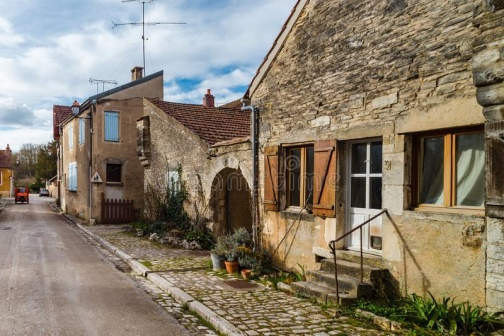Can you tell me more about the architectural style of the houses? The houses in the image showcase typical features of rural European architecture, often seen in small villages. They are constructed with natural stone walls and are topped with terracotta-colored tile roofs, which help in regulating indoor temperatures during different seasons. The simplicity of the structures, combined with practical elements like shutters, which protect against the elements, reflects a functional yet charming architectural style tailored to local needs and climatic conditions. 